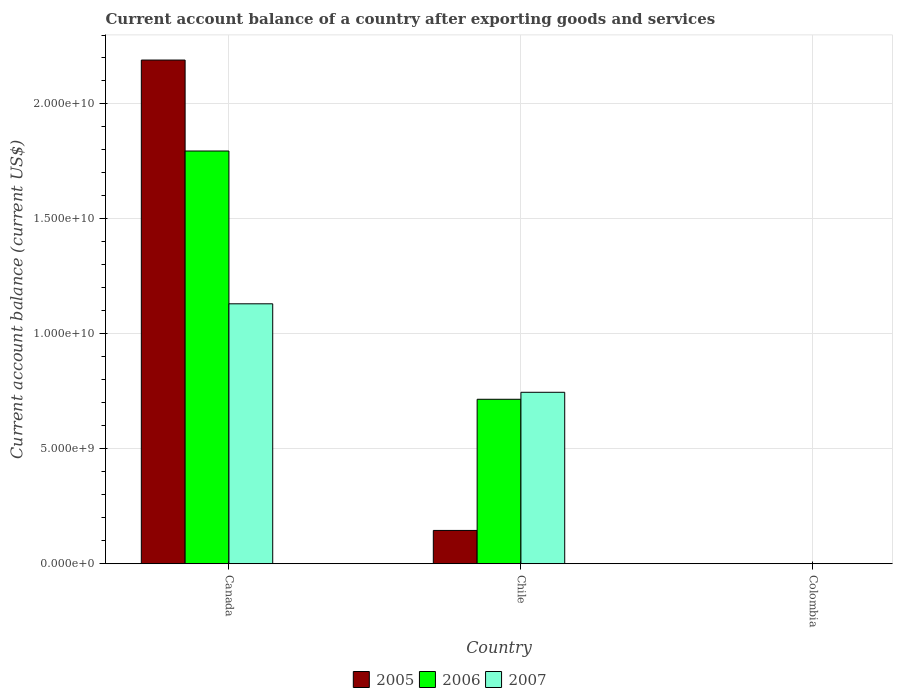How many bars are there on the 1st tick from the right?
Offer a very short reply. 0. What is the label of the 1st group of bars from the left?
Your response must be concise. Canada. What is the account balance in 2007 in Chile?
Provide a short and direct response. 7.46e+09. Across all countries, what is the maximum account balance in 2006?
Offer a very short reply. 1.80e+1. Across all countries, what is the minimum account balance in 2006?
Your answer should be very brief. 0. What is the total account balance in 2006 in the graph?
Give a very brief answer. 2.51e+1. What is the difference between the account balance in 2006 in Canada and that in Chile?
Offer a very short reply. 1.08e+1. What is the difference between the account balance in 2006 in Canada and the account balance in 2005 in Colombia?
Your response must be concise. 1.80e+1. What is the average account balance in 2006 per country?
Provide a short and direct response. 8.37e+09. What is the difference between the account balance of/in 2006 and account balance of/in 2005 in Chile?
Your answer should be very brief. 5.71e+09. What is the ratio of the account balance in 2006 in Canada to that in Chile?
Your response must be concise. 2.51. Is the account balance in 2006 in Canada less than that in Chile?
Offer a terse response. No. What is the difference between the highest and the lowest account balance in 2007?
Your answer should be compact. 1.13e+1. Is the sum of the account balance in 2006 in Canada and Chile greater than the maximum account balance in 2005 across all countries?
Make the answer very short. Yes. Is it the case that in every country, the sum of the account balance in 2006 and account balance in 2007 is greater than the account balance in 2005?
Keep it short and to the point. No. Are the values on the major ticks of Y-axis written in scientific E-notation?
Provide a short and direct response. Yes. Does the graph contain any zero values?
Ensure brevity in your answer.  Yes. Does the graph contain grids?
Your answer should be very brief. Yes. What is the title of the graph?
Offer a very short reply. Current account balance of a country after exporting goods and services. Does "2001" appear as one of the legend labels in the graph?
Provide a short and direct response. No. What is the label or title of the X-axis?
Your answer should be compact. Country. What is the label or title of the Y-axis?
Your answer should be very brief. Current account balance (current US$). What is the Current account balance (current US$) of 2005 in Canada?
Offer a terse response. 2.19e+1. What is the Current account balance (current US$) in 2006 in Canada?
Ensure brevity in your answer.  1.80e+1. What is the Current account balance (current US$) of 2007 in Canada?
Give a very brief answer. 1.13e+1. What is the Current account balance (current US$) in 2005 in Chile?
Offer a terse response. 1.45e+09. What is the Current account balance (current US$) of 2006 in Chile?
Your response must be concise. 7.15e+09. What is the Current account balance (current US$) in 2007 in Chile?
Provide a short and direct response. 7.46e+09. What is the Current account balance (current US$) in 2005 in Colombia?
Keep it short and to the point. 0. Across all countries, what is the maximum Current account balance (current US$) in 2005?
Your response must be concise. 2.19e+1. Across all countries, what is the maximum Current account balance (current US$) of 2006?
Provide a succinct answer. 1.80e+1. Across all countries, what is the maximum Current account balance (current US$) in 2007?
Keep it short and to the point. 1.13e+1. Across all countries, what is the minimum Current account balance (current US$) in 2007?
Provide a succinct answer. 0. What is the total Current account balance (current US$) in 2005 in the graph?
Your answer should be very brief. 2.34e+1. What is the total Current account balance (current US$) of 2006 in the graph?
Ensure brevity in your answer.  2.51e+1. What is the total Current account balance (current US$) in 2007 in the graph?
Your answer should be very brief. 1.88e+1. What is the difference between the Current account balance (current US$) of 2005 in Canada and that in Chile?
Your answer should be very brief. 2.05e+1. What is the difference between the Current account balance (current US$) in 2006 in Canada and that in Chile?
Provide a succinct answer. 1.08e+1. What is the difference between the Current account balance (current US$) of 2007 in Canada and that in Chile?
Your response must be concise. 3.85e+09. What is the difference between the Current account balance (current US$) in 2005 in Canada and the Current account balance (current US$) in 2006 in Chile?
Give a very brief answer. 1.48e+1. What is the difference between the Current account balance (current US$) of 2005 in Canada and the Current account balance (current US$) of 2007 in Chile?
Your answer should be very brief. 1.45e+1. What is the difference between the Current account balance (current US$) in 2006 in Canada and the Current account balance (current US$) in 2007 in Chile?
Offer a terse response. 1.05e+1. What is the average Current account balance (current US$) in 2005 per country?
Keep it short and to the point. 7.79e+09. What is the average Current account balance (current US$) of 2006 per country?
Ensure brevity in your answer.  8.37e+09. What is the average Current account balance (current US$) in 2007 per country?
Your answer should be very brief. 6.26e+09. What is the difference between the Current account balance (current US$) in 2005 and Current account balance (current US$) in 2006 in Canada?
Your answer should be very brief. 3.96e+09. What is the difference between the Current account balance (current US$) of 2005 and Current account balance (current US$) of 2007 in Canada?
Keep it short and to the point. 1.06e+1. What is the difference between the Current account balance (current US$) in 2006 and Current account balance (current US$) in 2007 in Canada?
Offer a terse response. 6.65e+09. What is the difference between the Current account balance (current US$) in 2005 and Current account balance (current US$) in 2006 in Chile?
Make the answer very short. -5.71e+09. What is the difference between the Current account balance (current US$) of 2005 and Current account balance (current US$) of 2007 in Chile?
Your answer should be very brief. -6.01e+09. What is the difference between the Current account balance (current US$) of 2006 and Current account balance (current US$) of 2007 in Chile?
Your answer should be compact. -3.04e+08. What is the ratio of the Current account balance (current US$) of 2005 in Canada to that in Chile?
Make the answer very short. 15.12. What is the ratio of the Current account balance (current US$) in 2006 in Canada to that in Chile?
Your answer should be compact. 2.51. What is the ratio of the Current account balance (current US$) of 2007 in Canada to that in Chile?
Your answer should be compact. 1.52. What is the difference between the highest and the lowest Current account balance (current US$) in 2005?
Ensure brevity in your answer.  2.19e+1. What is the difference between the highest and the lowest Current account balance (current US$) of 2006?
Ensure brevity in your answer.  1.80e+1. What is the difference between the highest and the lowest Current account balance (current US$) of 2007?
Your response must be concise. 1.13e+1. 